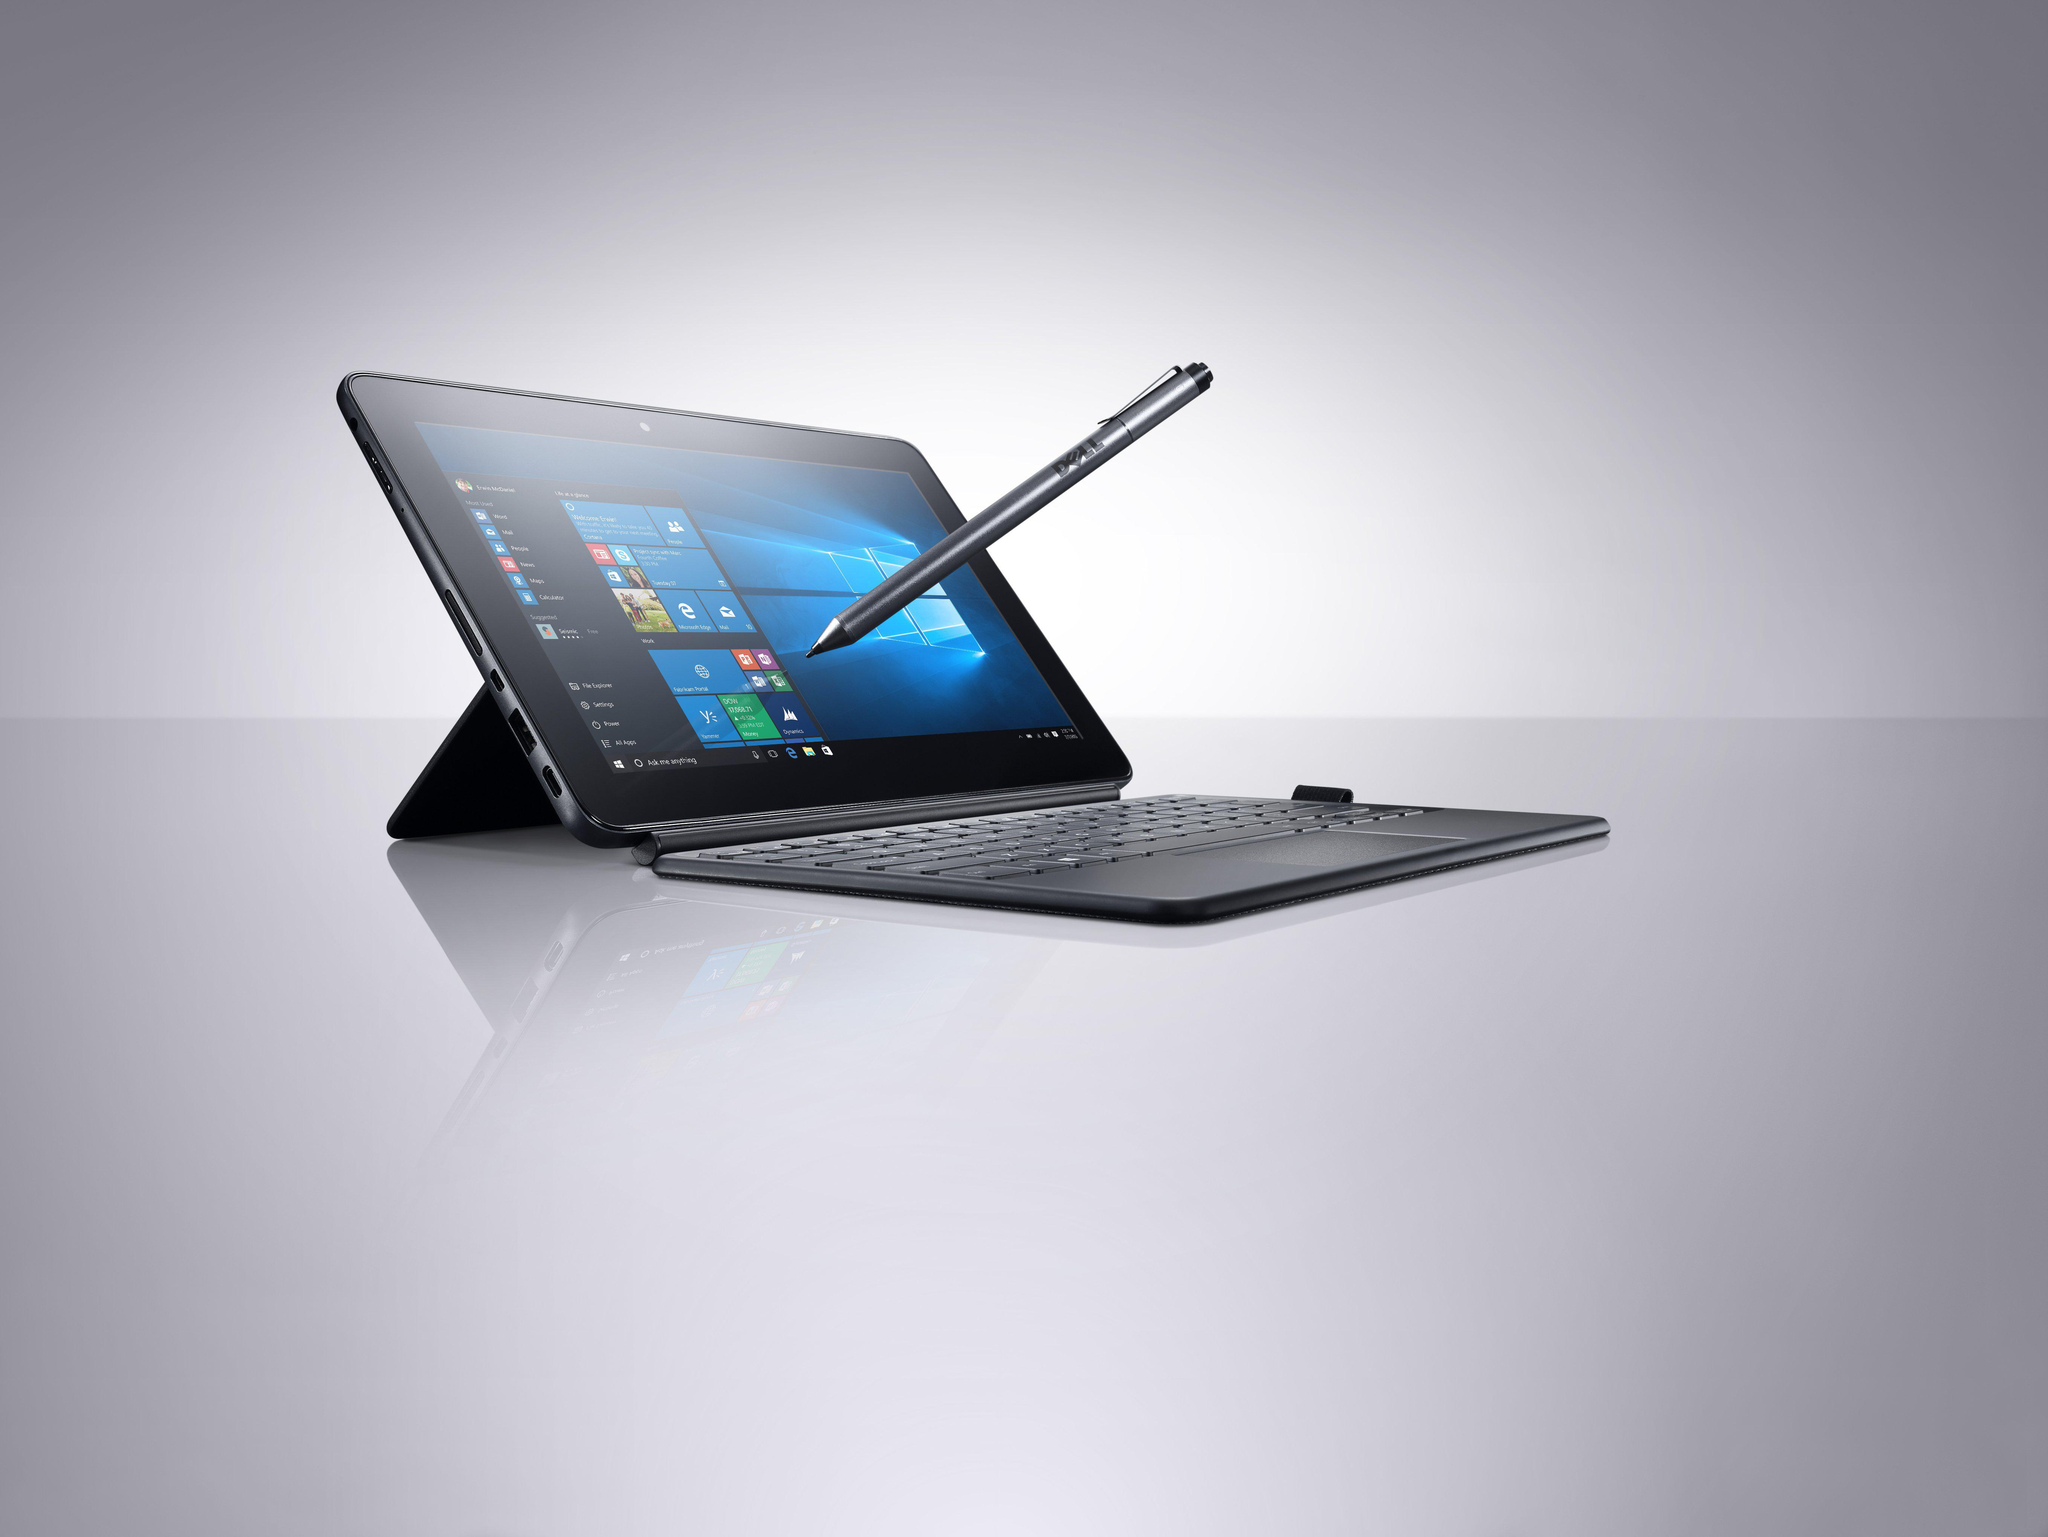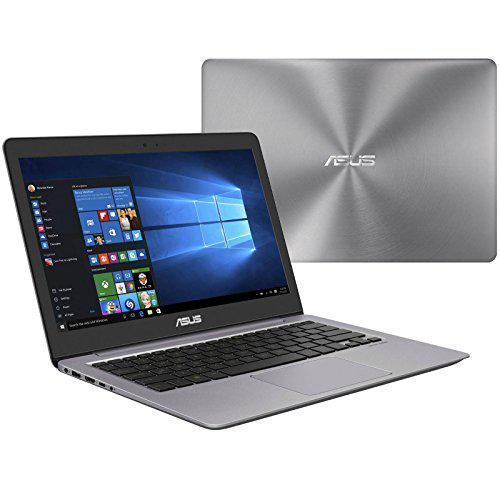The first image is the image on the left, the second image is the image on the right. Given the left and right images, does the statement "A pen is touching the screen in one of the images." hold true? Answer yes or no. Yes. The first image is the image on the left, the second image is the image on the right. Assess this claim about the two images: "Right image shows a laptop displayed like an inverted book with its pages fanning out.". Correct or not? Answer yes or no. No. 